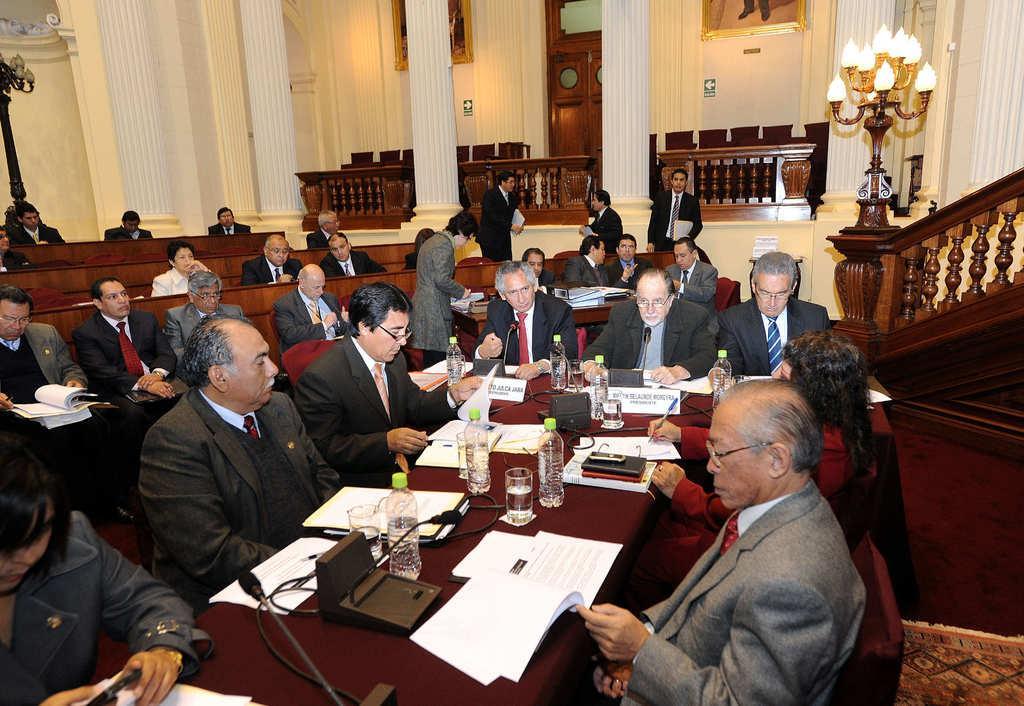Describe this image in one or two sentences. In this image there are desks, there are objects on the desks, there are chairs, there are persons sitting on the chairs, there are lights, there is floor towards the right of the image, there is a mat on the floor, there are pillars towards the top of the image, there is a wall towards the top of the image, there is a door, there are photo frames towards the top of the image. 